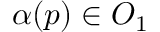Convert formula to latex. <formula><loc_0><loc_0><loc_500><loc_500>\alpha ( p ) \in O _ { 1 }</formula> 